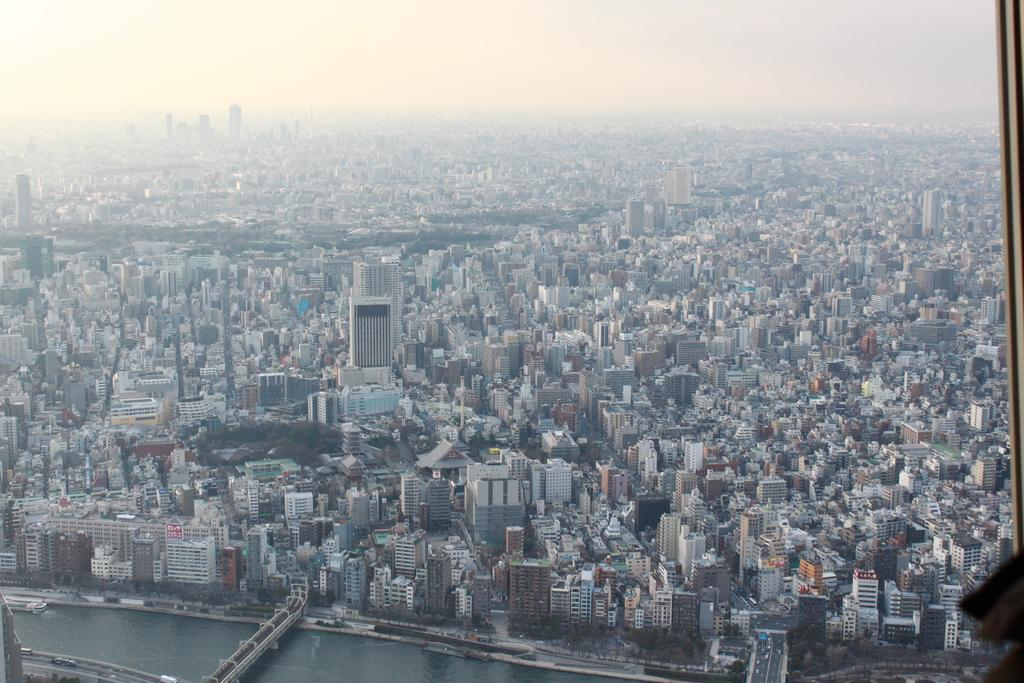What type of natural body of water is present in the image? There is a lake in the image. What type of man-made structures can be seen in the image? There are buildings in the image. What type of vegetation is present in the image? There are trees in the image. From what perspective is the image taken? The image is taken from a top view. Can you see anyone jumping over the lake in the image? There is no one jumping over the lake in the image. Is there a bike visible in the image? There is no bike present in the image. 